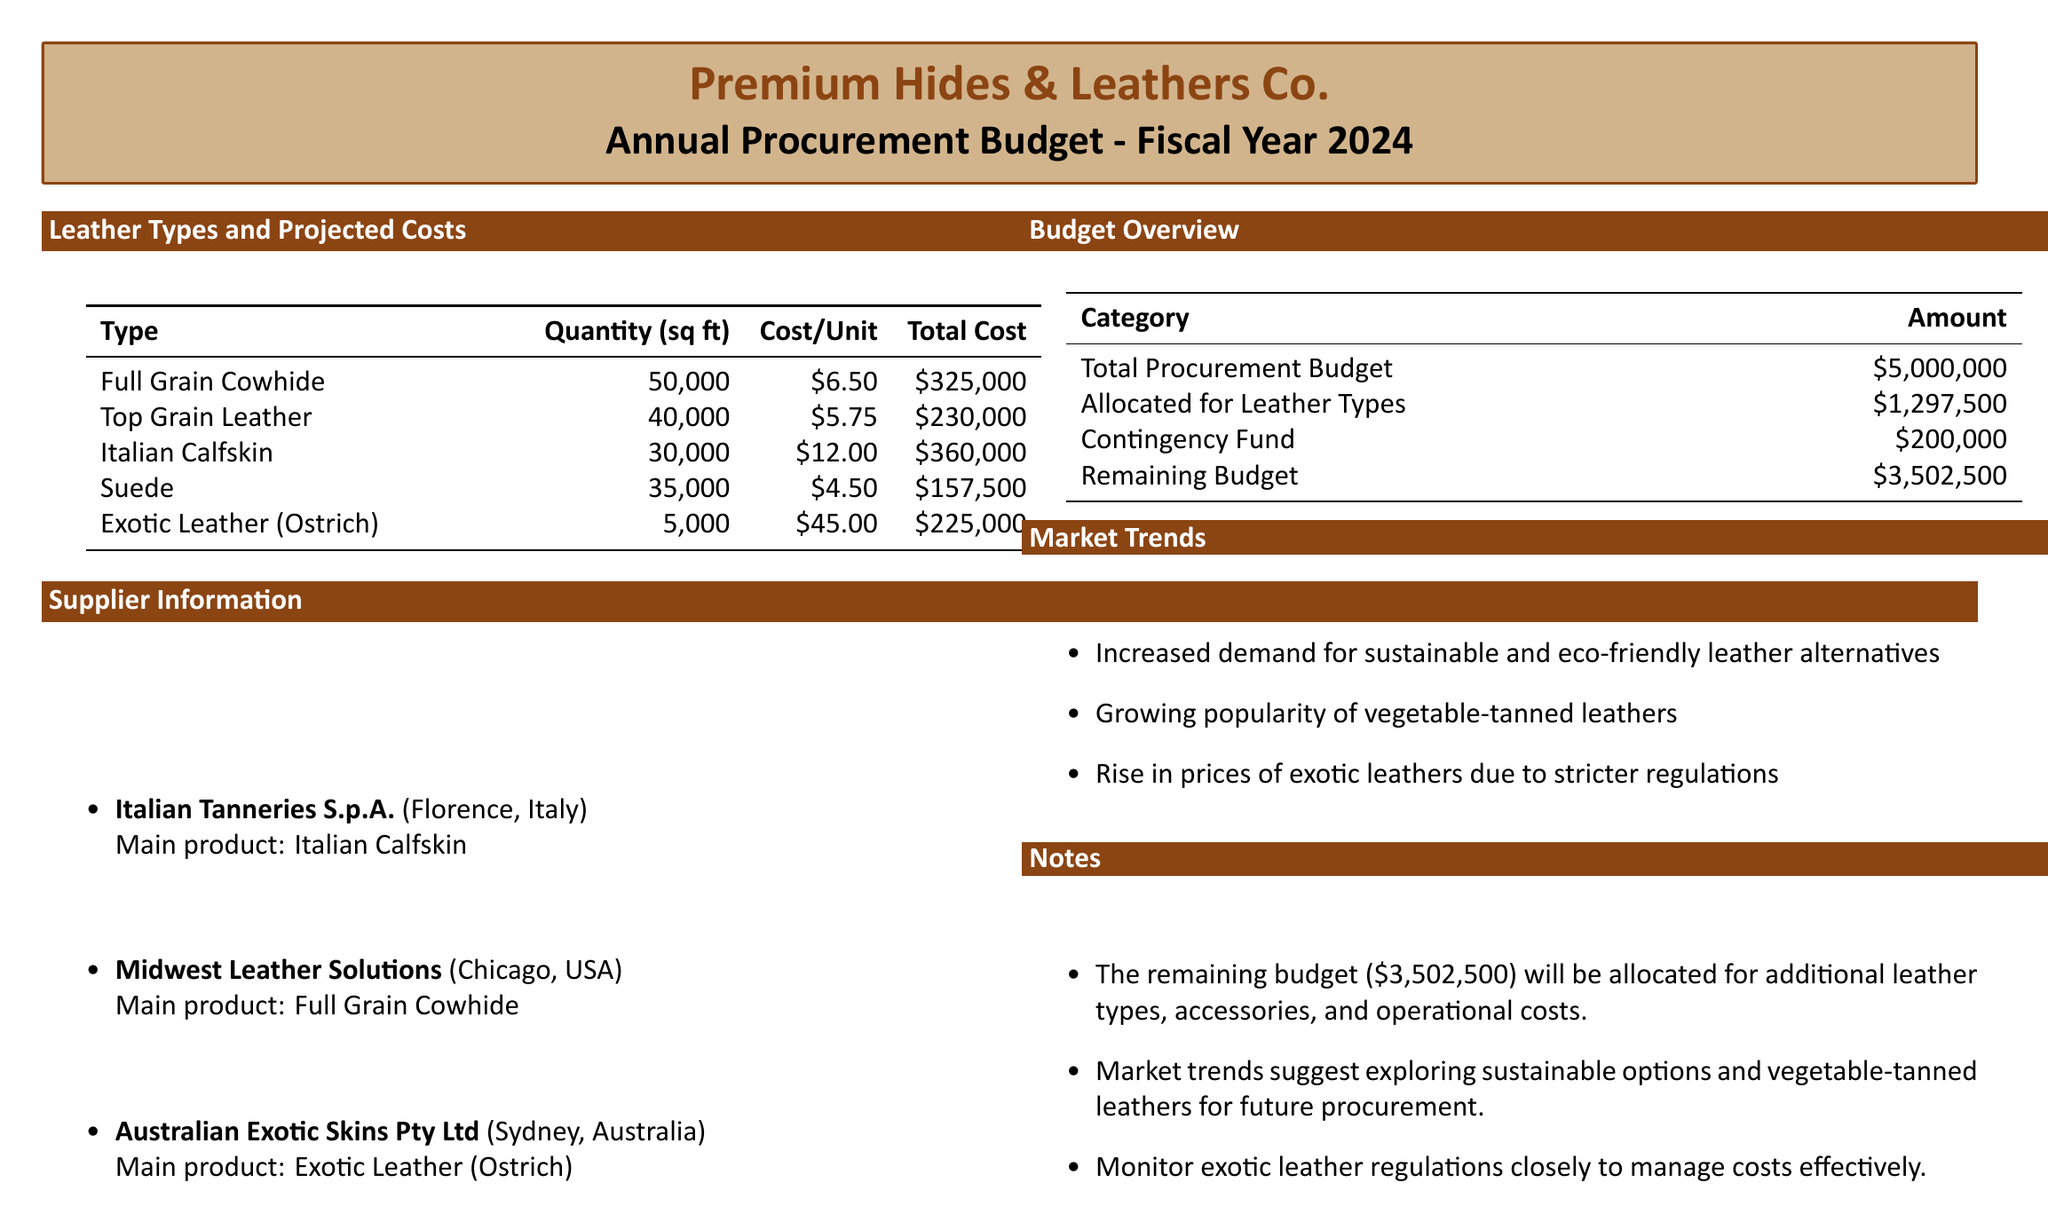what is the total procurement budget? The total procurement budget is explicitly stated in the document.
Answer: $5,000,000 how much is allocated for the leather types? The budget allocated for various leather types is mentioned in the budget overview section.
Answer: $1,297,500 what is the cost per unit of Italian Calfskin? The cost per unit for Italian Calfskin is provided in the leather types table.
Answer: $12.00 which supplier specializes in full grain cowhide? The document lists the supplier information, including their main products.
Answer: Midwest Leather Solutions how many square feet of Suede are projected for procurement? The quantity of Suede required is listed in the leather types table.
Answer: 35,000 what is the contingency fund amount? The contingency fund is specifically mentioned in the budget overview section.
Answer: $200,000 what is the total cost for Exotic Leather (Ostrich)? The total cost for Exotic Leather is provided in the leather types table.
Answer: $225,000 what are the market trends mentioned? The document lists market trends, summarizing current industry observations.
Answer: Increased demand for sustainable and eco-friendly leather alternatives what is the remaining budget after allocations? The document states the remaining budget after leather type allocations and contingency.
Answer: $3,502,500 which country does Italian Tanneries S.p.A. operate in? The supplier information indicates the location of Italian Tanneries S.p.A.
Answer: Italy 